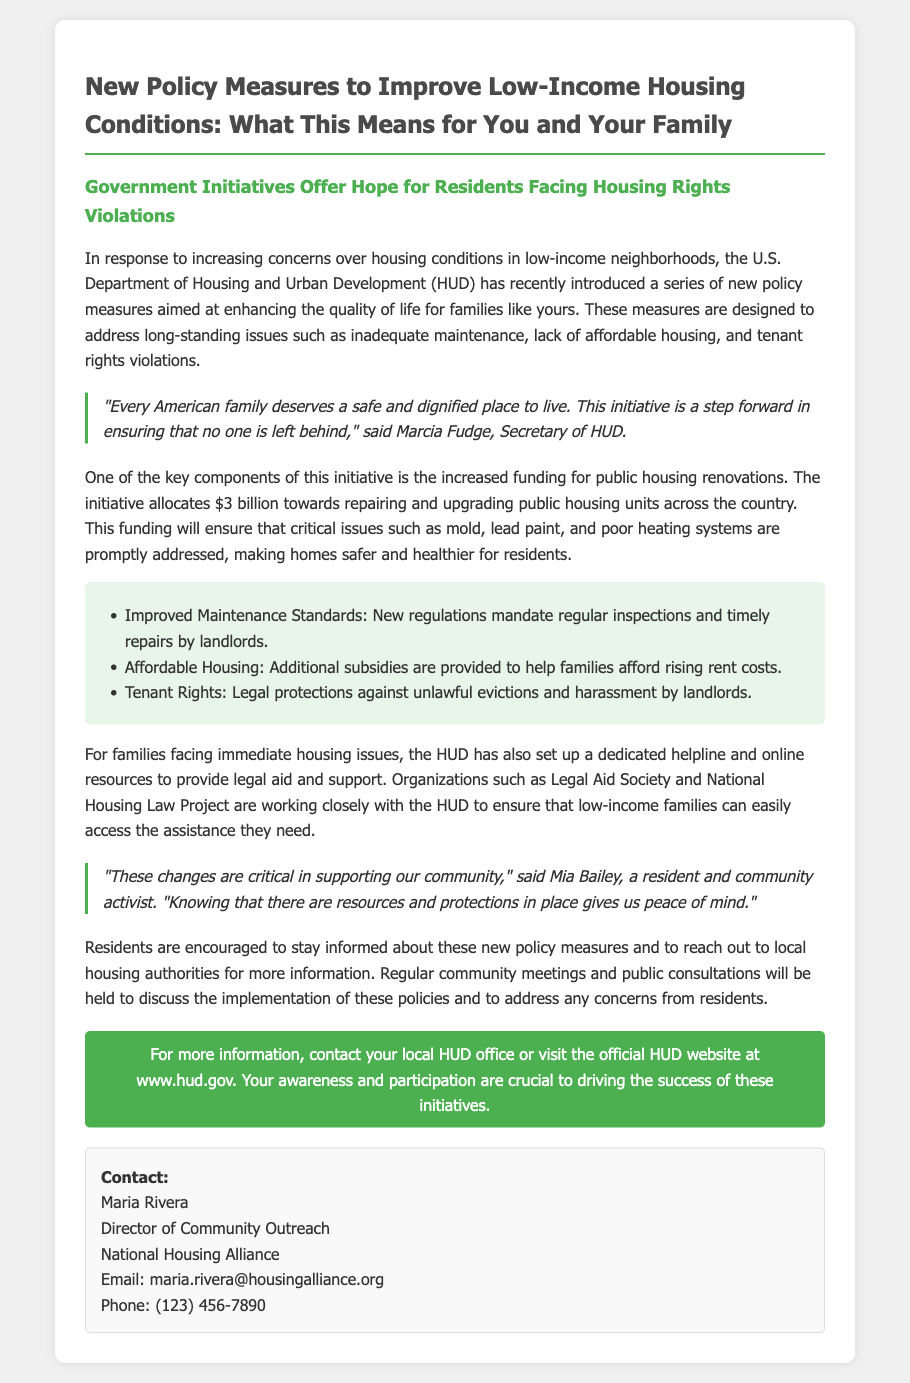What is the total funding allocated for public housing renovations? The document states that the initiative allocates $3 billion towards repairing and upgrading public housing units.
Answer: $3 billion Who is the Secretary of HUD? The document names Marcia Fudge as the Secretary of HUD.
Answer: Marcia Fudge What are the new regulations related to maintenance? The document mentions that new regulations mandate regular inspections and timely repairs by landlords.
Answer: Regular inspections and timely repairs What does the initiative aim to address? The document outlines that the initiative is designed to address issues such as inadequate maintenance, lack of affordable housing, and tenant rights violations.
Answer: Inadequate maintenance, lack of affordable housing, tenant rights violations What types of organizations are working with HUD? According to the document, organizations such as Legal Aid Society and National Housing Law Project are collaborating with HUD.
Answer: Legal Aid Society and National Housing Law Project Who can residents contact for more information? The document provides the contact information for Maria Rivera, Director of Community Outreach at the National Housing Alliance.
Answer: Maria Rivera What is the purpose of community meetings? The document states that regular community meetings will be held to discuss the implementation of these policies and to address any concerns from residents.
Answer: Discuss implementation and address concerns What is the primary goal of the new policy measures? The document indicates that the primary goal is to improve low-income housing conditions for families.
Answer: Improve low-income housing conditions 